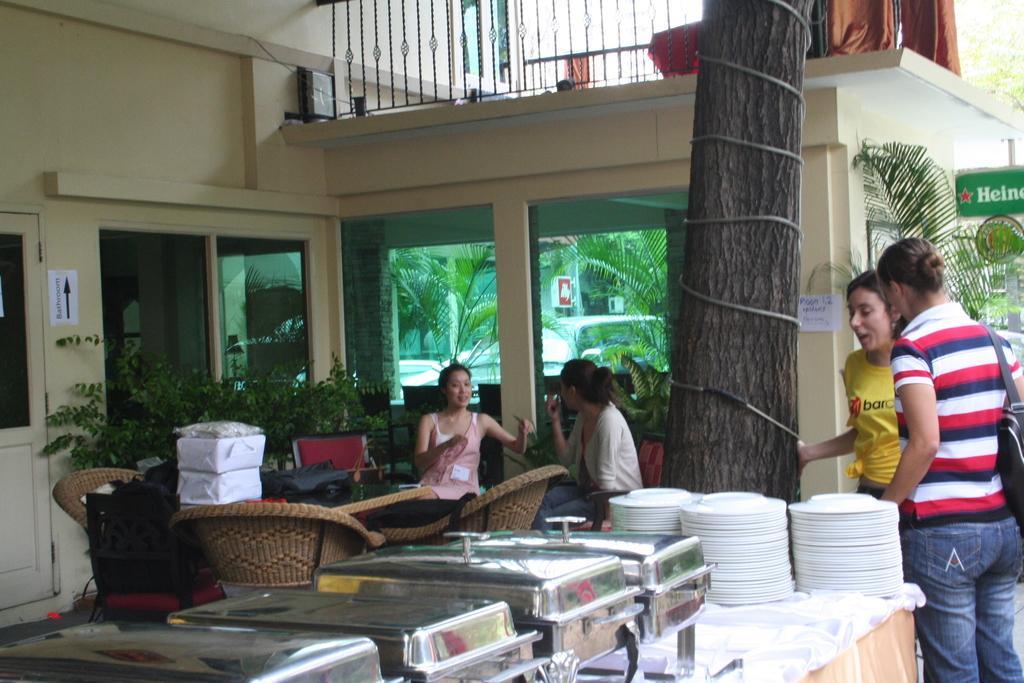Describe this image in one or two sentences. In this picture we can see a table and on the table we can see planets and few dish containers. Here we can see two persons sitting on a chain and talking. On the background we can see doors and trees. This is a building. At the right side of the picture we can see two women standing and talking. This is a board. 